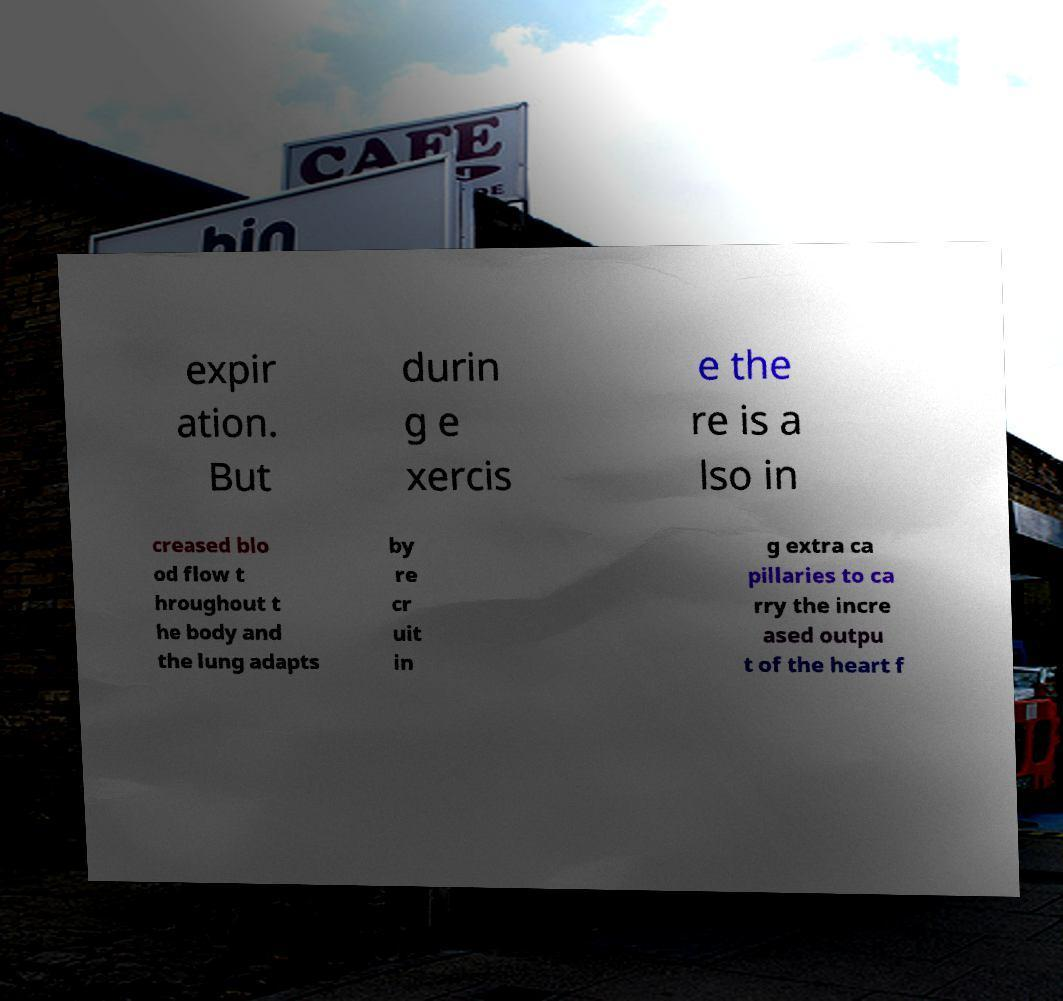There's text embedded in this image that I need extracted. Can you transcribe it verbatim? expir ation. But durin g e xercis e the re is a lso in creased blo od flow t hroughout t he body and the lung adapts by re cr uit in g extra ca pillaries to ca rry the incre ased outpu t of the heart f 